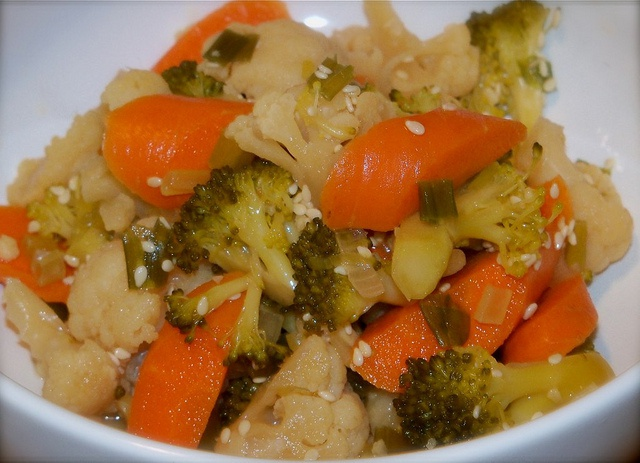Describe the objects in this image and their specific colors. I can see bowl in olive, tan, darkgray, red, and maroon tones, broccoli in gray, olive, and maroon tones, carrot in gray, red, brown, and maroon tones, broccoli in gray, olive, black, and maroon tones, and carrot in gray, red, brown, and maroon tones in this image. 